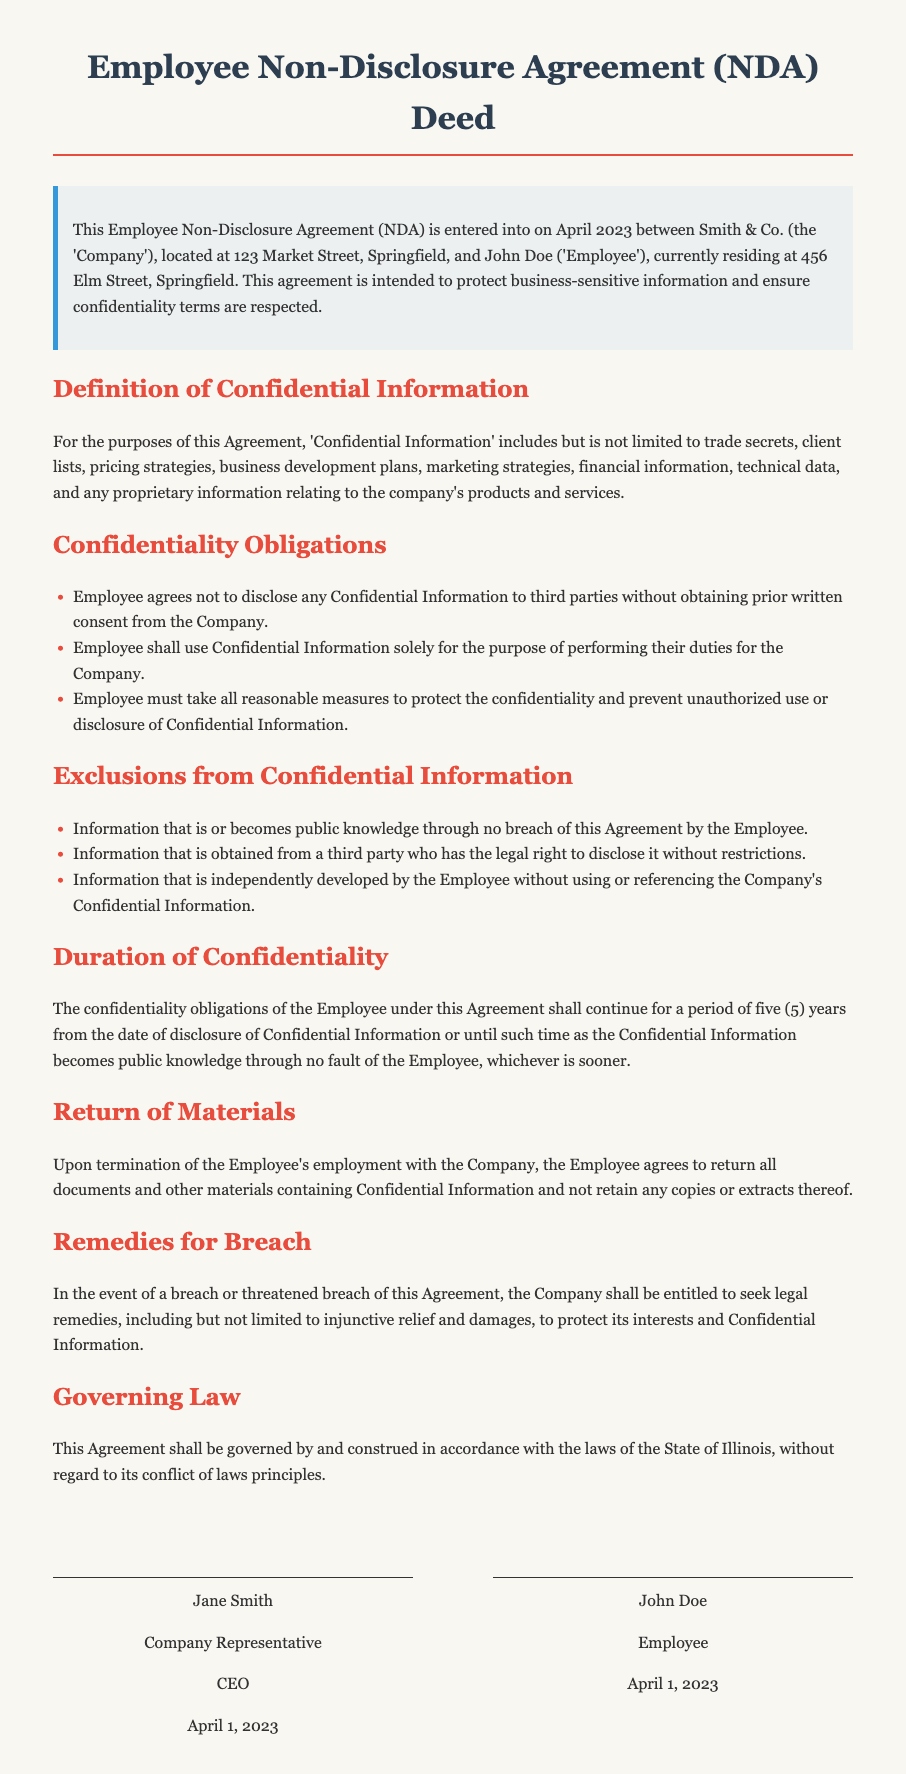What is the name of the company? The name of the company is mentioned in the introduction section of the document.
Answer: Smith & Co Who is the employee? The name of the employee is stated in the introduction section of the document.
Answer: John Doe When was the agreement signed? The signing date is indicated in the introductory paragraph and signatures section of the document.
Answer: April 2023 What is the duration of confidentiality? The duration of confidentiality is specified in the relevant section of the document.
Answer: five (5) years What must the employee do upon termination? This obligation is detailed in the Return of Materials section of the document.
Answer: return all documents and other materials What are the remedies for breach? The remedies for breach are described in the Remedies for Breach section of the document.
Answer: injunctive relief and damages What information is excluded from Confidential Information? The Exclusions from Confidential Information section lists specific cases.
Answer: public knowledge Which law governs the agreement? The Governing Law section indicates which laws apply to this document.
Answer: State of Illinois What title does Jane Smith hold? The title of the company representative is noted under the signature section.
Answer: CEO 